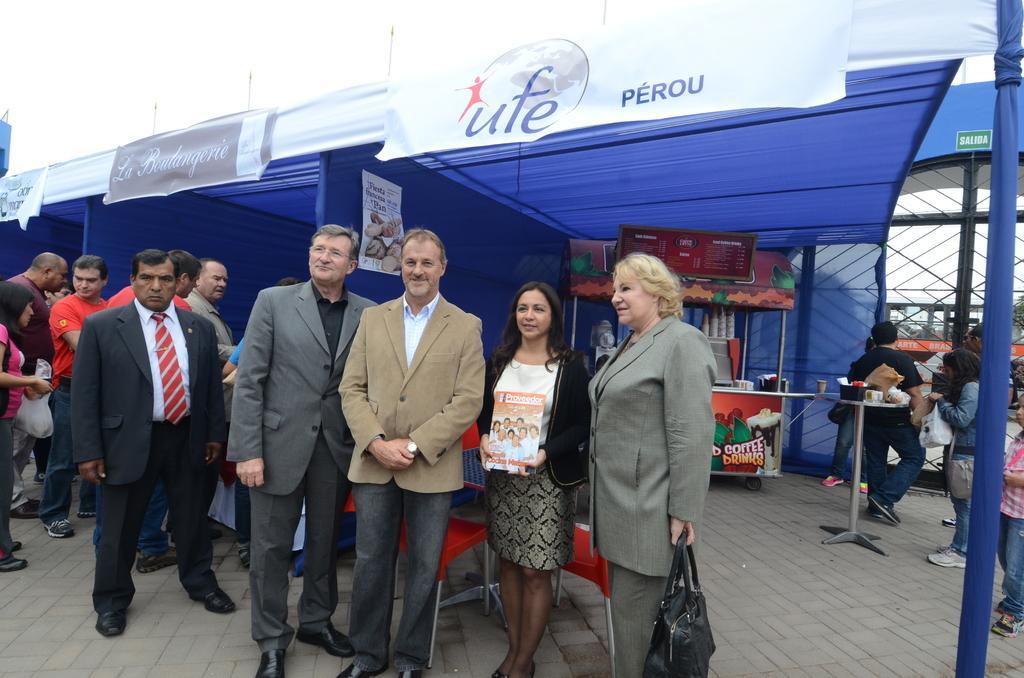How would you summarize this image in a sentence or two? In this image I can see few persons are standing on the ground. I can see the blue and white colored rent, a store, few other persons and the sky in the background. 